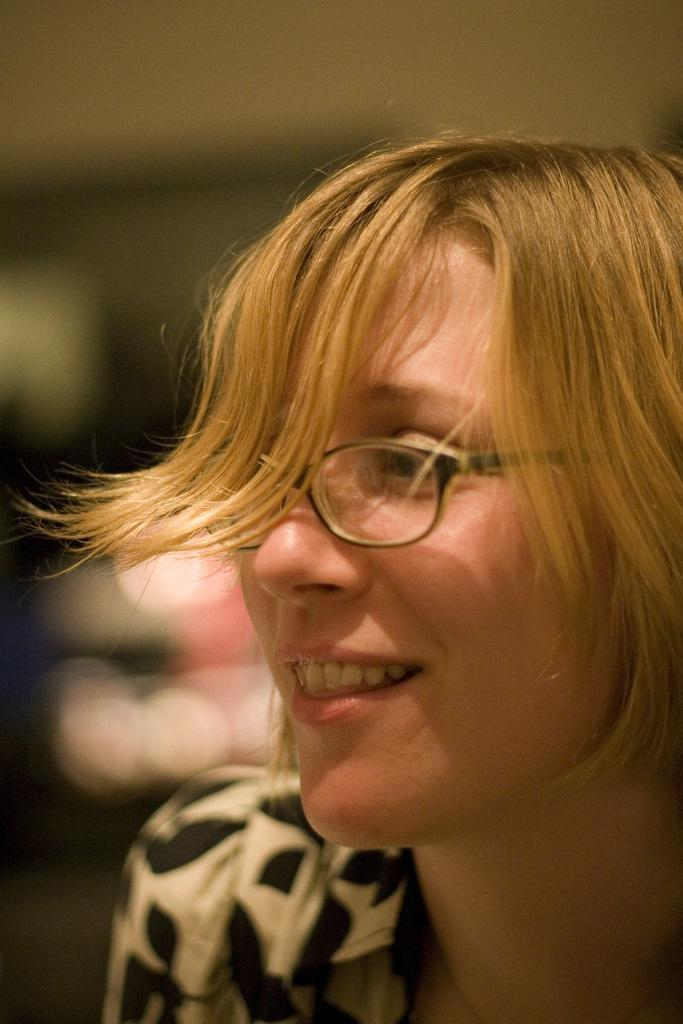Who is the main subject in the image? There is a girl in the image. What is the girl wearing in the image? The girl is wearing spectacles. What type of jeans is the girl wearing in the image? There is no mention of jeans in the image, as the girl is only described as wearing spectacles. 